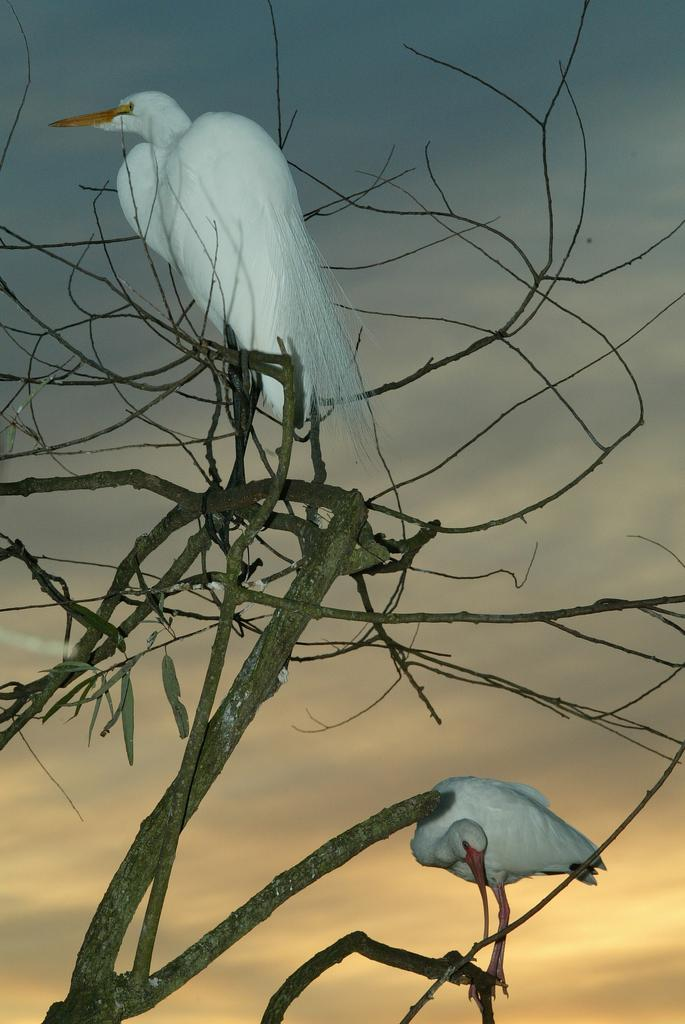What type of tree is depicted in the image? There is a dried tree in the image. What is attached to the tree? There is a stem with dried leaves in the image. What animals can be seen on the tree? There are two birds on the tree in the image. What can be seen in the background of the image? There is a colorful sky in the background of the image. How many snails can be seen crawling on the coast in the image? There is no coast or snails present in the image. What type of fang is visible on the tree in the image? There are no fangs present in the image; it features a dried tree with a stem and two birds. 